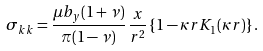<formula> <loc_0><loc_0><loc_500><loc_500>\sigma _ { k k } = \frac { \mu b _ { y } ( 1 + \nu ) } { \pi ( 1 - \nu ) } \, \frac { x } { r ^ { 2 } } \left \{ 1 - \kappa r K _ { 1 } ( \kappa r ) \right \} .</formula> 